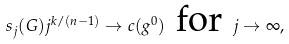Convert formula to latex. <formula><loc_0><loc_0><loc_500><loc_500>s _ { j } ( G ) j ^ { k / ( n - 1 ) } \to c ( g ^ { 0 } ) \text { for } j \to \infty ,</formula> 